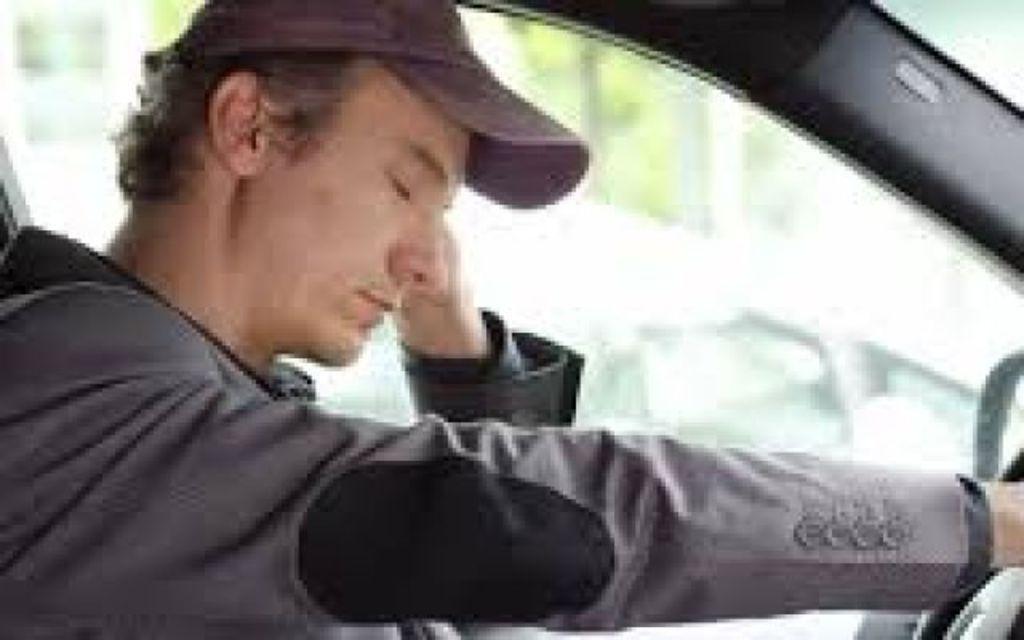Describe this image in one or two sentences. This picture is taken inside the car. In this image, we can see a man sitting and holding a steering in his hand. In the background, we can see a glass window. Outside of the glass window, we can see green color and another vehicle. 